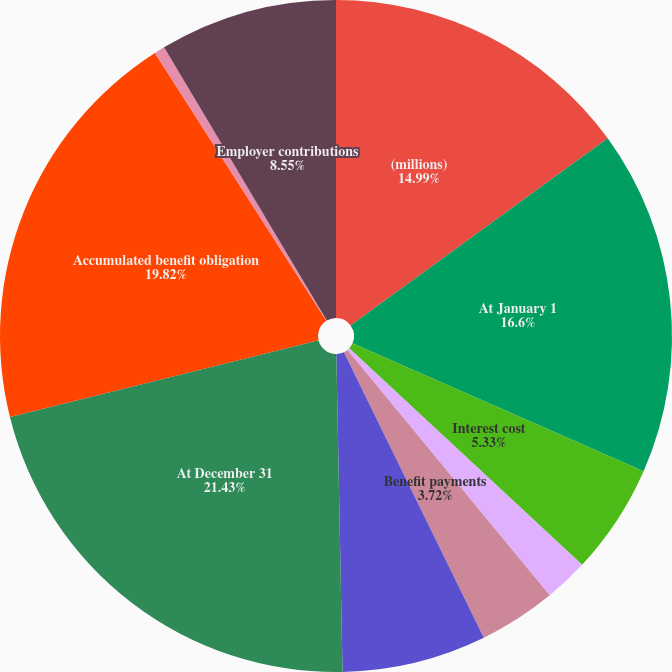<chart> <loc_0><loc_0><loc_500><loc_500><pie_chart><fcel>(millions)<fcel>At January 1<fcel>Interest cost<fcel>Actuarial loss (gain)<fcel>Benefit payments<fcel>Change in discount rate<fcel>At December 31<fcel>Accumulated benefit obligation<fcel>Actual return on plan assets<fcel>Employer contributions<nl><fcel>14.99%<fcel>16.6%<fcel>5.33%<fcel>2.11%<fcel>3.72%<fcel>6.94%<fcel>21.43%<fcel>19.82%<fcel>0.51%<fcel>8.55%<nl></chart> 